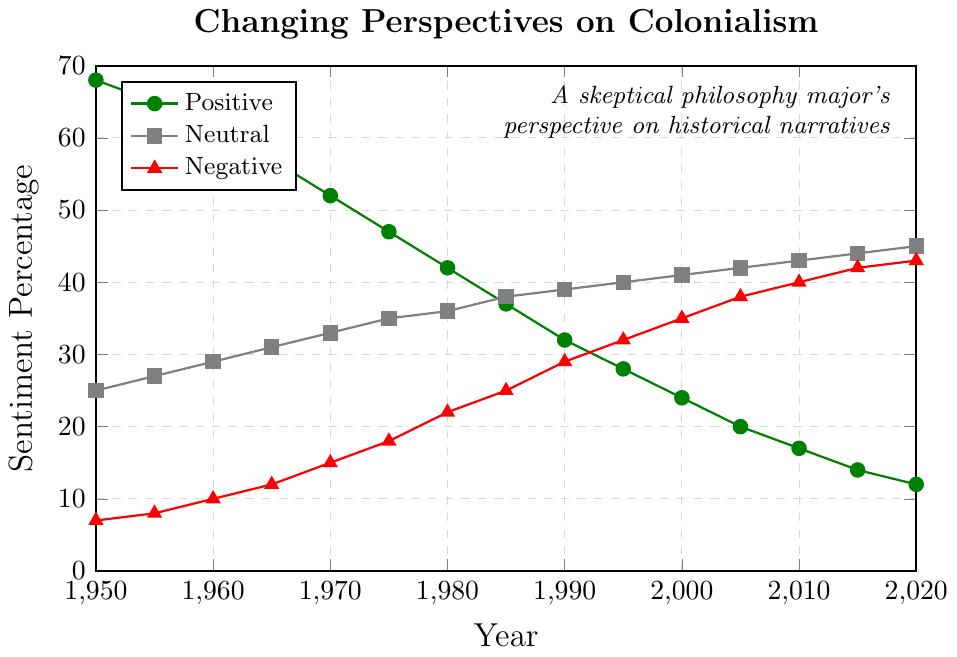What is the general trend of positive sentiment from 1950 to 2020? The positive sentiment consistently decreases over time. In 1950, it starts at 68%, and by 2020, it reduces to 12%.
Answer: Positive sentiment consistently decreases What is the difference between the neutral sentiment in 1950 and 2020? In 1950, neutral sentiment is 25%. In 2020, it is 45%. The difference is 45% - 25% = 20%.
Answer: 20% Which year has the highest negative sentiment and what is that value? By examining the negative sentiment values, 2020 has the highest negative sentiment at 43%.
Answer: 2020, 43% Compare the positive and negative sentiment percentages in 1980. Which is greater and by how much? In 1980, the positive sentiment is 42%, and the negative sentiment is 22%. The positive sentiment is greater by 42% - 22% = 20%.
Answer: Positive sentiment by 20% In what year do positive and negative sentiments first cross paths, and what are their values at that point? The first crossing point occurs in 1995, where positive sentiment is 28% and negative sentiment is 32%.
Answer: 1995, Positive: 28%, Negative: 32% How much does the neutral sentiment increase between the years 1960 and 2010? The neutral sentiment in 1960 is 29%, and in 2010 it is 43%. The increase is 43% - 29% = 14%.
Answer: 14% What is the average positive sentiment percentage for the decades represented by the years 1950, 1960, 1970, 1980, 1990, and 2000? The positive sentiment values are 68% for 1950, 61% for 1960, 52% for 1970, 42% for 1980, 32% for 1990, and 24% for 2000. The average is calculated as (68 + 61 + 52 + 42 + 32 + 24) / 6 = 46.5%.
Answer: 46.5% What colors represent positive, neutral, and negative sentiment in the plot? Positive sentiment is represented by green, neutral by gray, and negative by red.
Answer: Positive: green, Neutral: gray, Negative: red Are there any years where all three sentiment categories (positive, neutral, negative) change in the same direction (either increase or decrease)? No, there are no years where all three sentiment categories increase or decrease simultaneously. The positive sentiment decreases while neutral and negative sentiments generally increase over time.
Answer: No What’s the median value of the negative sentiment data points from 1950 to 2020? The negative sentiment values from 1950 to 2020 are: 7, 8, 10, 12, 15, 18, 22, 25, 29, 32, 35, 38, 40, 42, 43. The median is the middle value when the data points are arranged in order, which is (8th and 9th values)/2 = (25+29)/2 = 27%.
Answer: 27% 